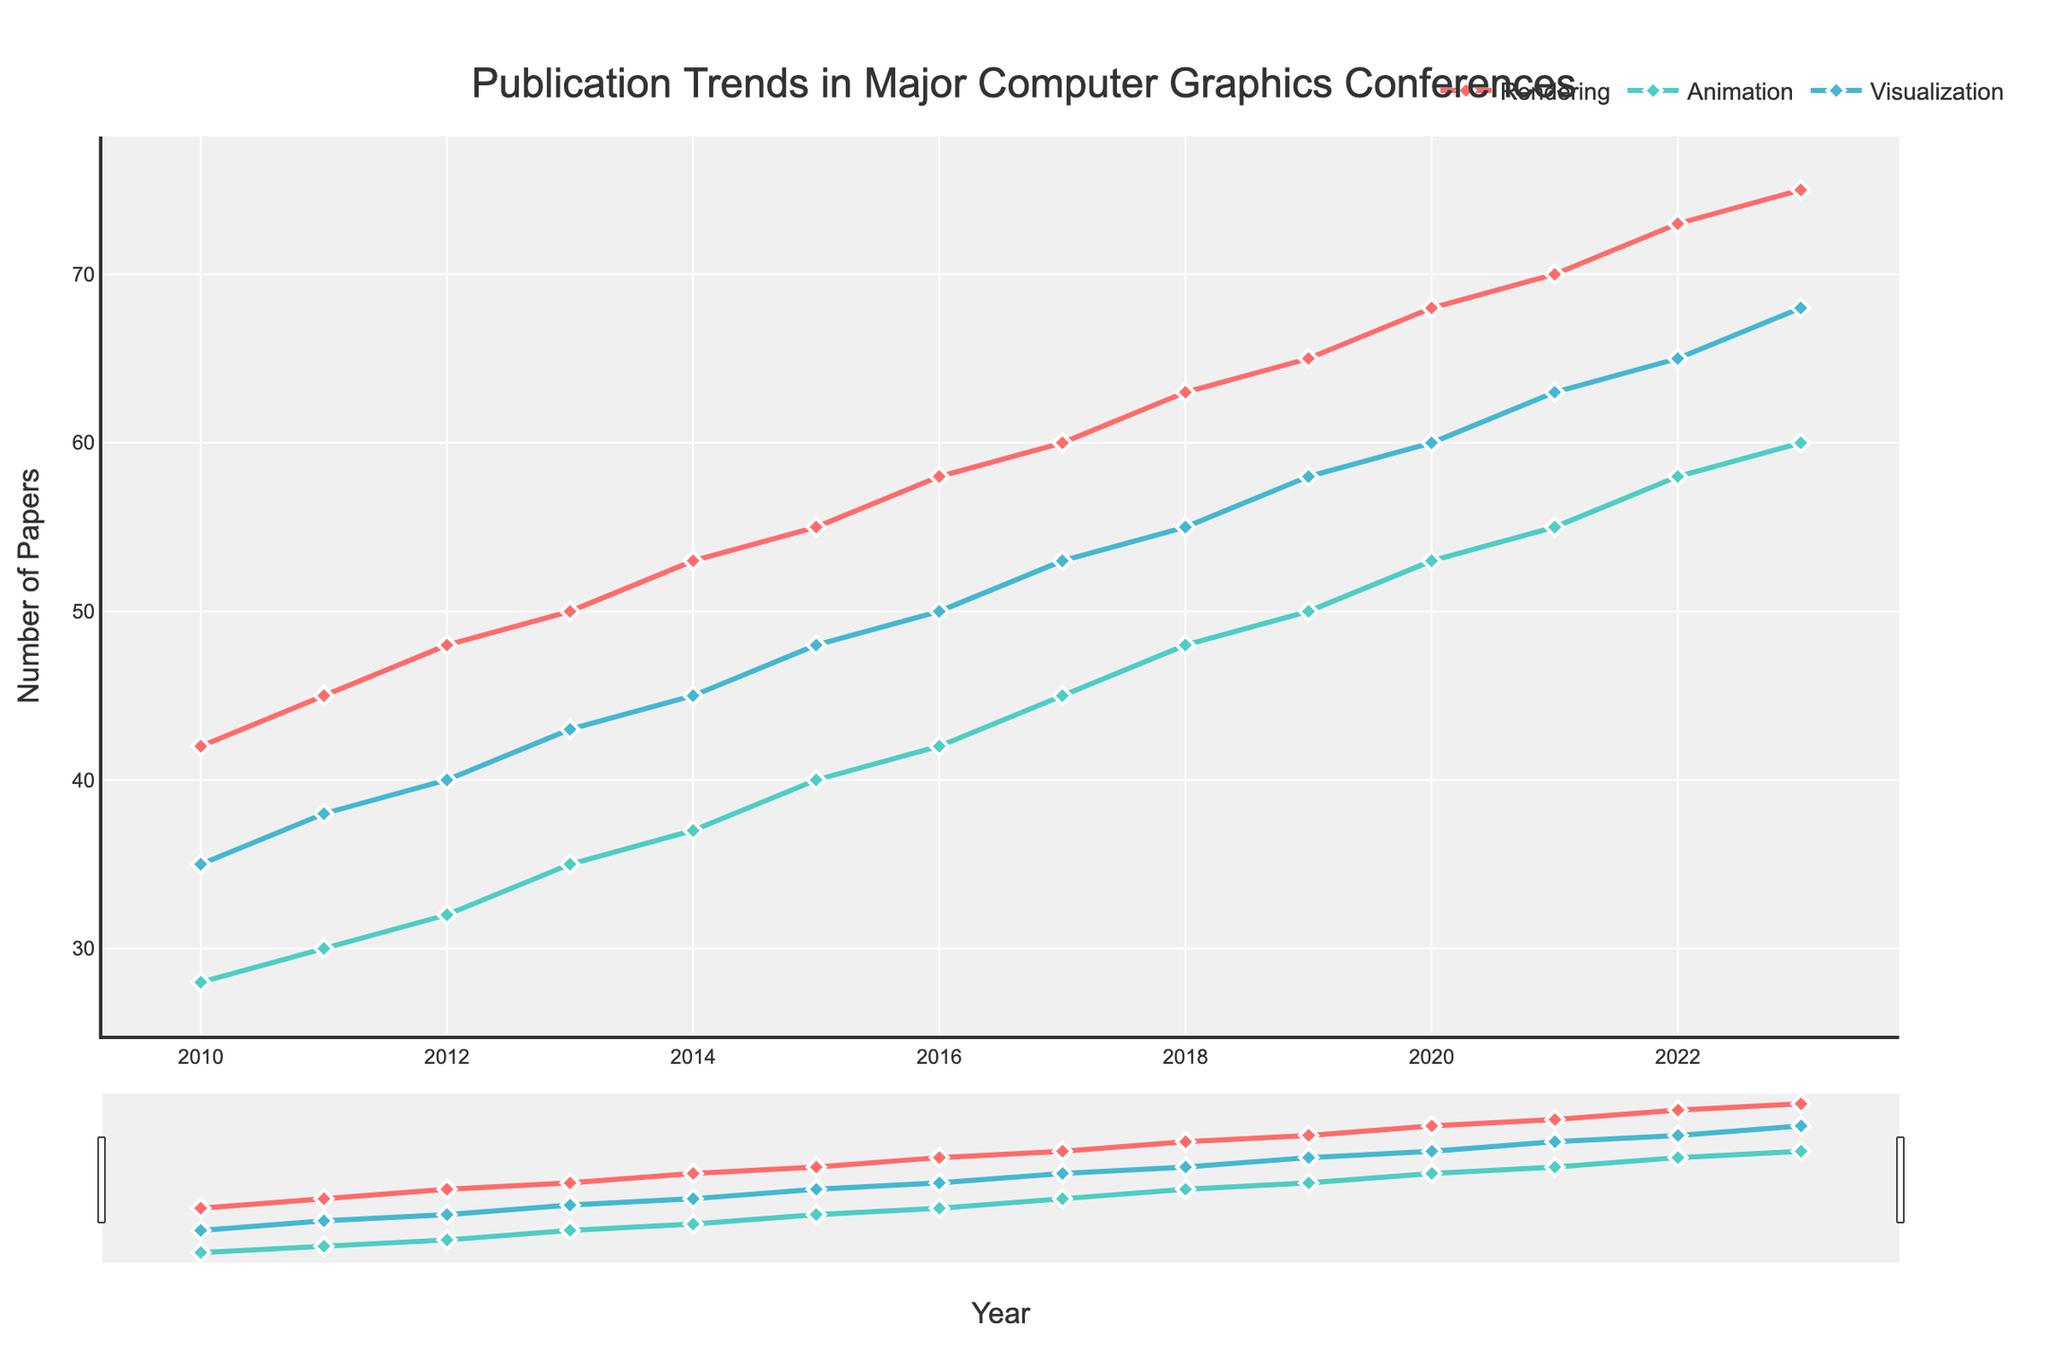What's the trend in the number of papers published in the 'Rendering' subfield over the years? The number of papers in 'Rendering' increases consistently from 2010 to 2023. It starts at 42 in 2010 and gradually rises to 75 in 2023.
Answer: Increasing trend In which year did 'Visualization' overtake 'Animation' in the number of publications? By observing the lines, 'Visualization' overtakes 'Animation' in 2013 as the visualization line goes above the animation line starting in that year.
Answer: 2013 What is the total number of papers published in 'Rendering' and 'Animation' in 2015? The number of papers in 'Rendering' is 55 and in 'Animation' is 40. Adding them together gives 55 + 40 = 95.
Answer: 95 Between 2010 and 2023, which subfield had the largest increase in the number of publications? By taking the starting and ending values of each subfield and calculating the difference: 'Rendering' (75-42=33), 'Animation' (60-28=32), 'Visualization' (68-35=33). Both 'Rendering' and 'Visualization' had an increase of 33.
Answer: Rendering and Visualization How does the number of papers in 'Visualization' in 2023 compare to the number of papers in 'Animation' in the same year? In 2023, the number of papers in 'Visualization' is 68 and in 'Animation' is 60. Therefore, 'Visualization' has 68 - 60 = 8 more papers than 'Animation'.
Answer: 8 more papers in Visualization By how much did the number of 'Animation' papers increase from 2016 to 2019? The number of papers in 'Animation' in 2016 was 42 and in 2019 it was 50. The increase is 50 - 42 = 8 papers.
Answer: 8 papers What was the growth rate for 'Rendering' between 2010 and 2023? The number of 'Rendering' papers in 2010 was 42, and in 2023 it was 75. The growth rate can be calculated as ((75 - 42) / 42) * 100 = 78.57%.
Answer: 78.57% Compare the number of papers in 'Visualization' and 'Rendering' in 2017. The number of papers in 'Visualization' in 2017 was 53 and in 'Rendering' was 60. Therefore, 'Rendering' had more papers by 60 - 53 = 7.
Answer: Rendering had 7 more papers What is the average number of papers published in 'Visualization' from 2010 to 2013? Summing the values for 'Visualization' from 2010 to 2013: 35 + 38 + 40 + 43 = 156. Dividing by 4 gives 156 / 4 = 39.
Answer: 39 Which subfield shows the most consistent growth over the years? By observing the lines, all subfields show consistent growth, but 'Rendering' and 'Visualization' appear to have a steady and smooth increase without any fluctuations.
Answer: Rendering and Visualization 